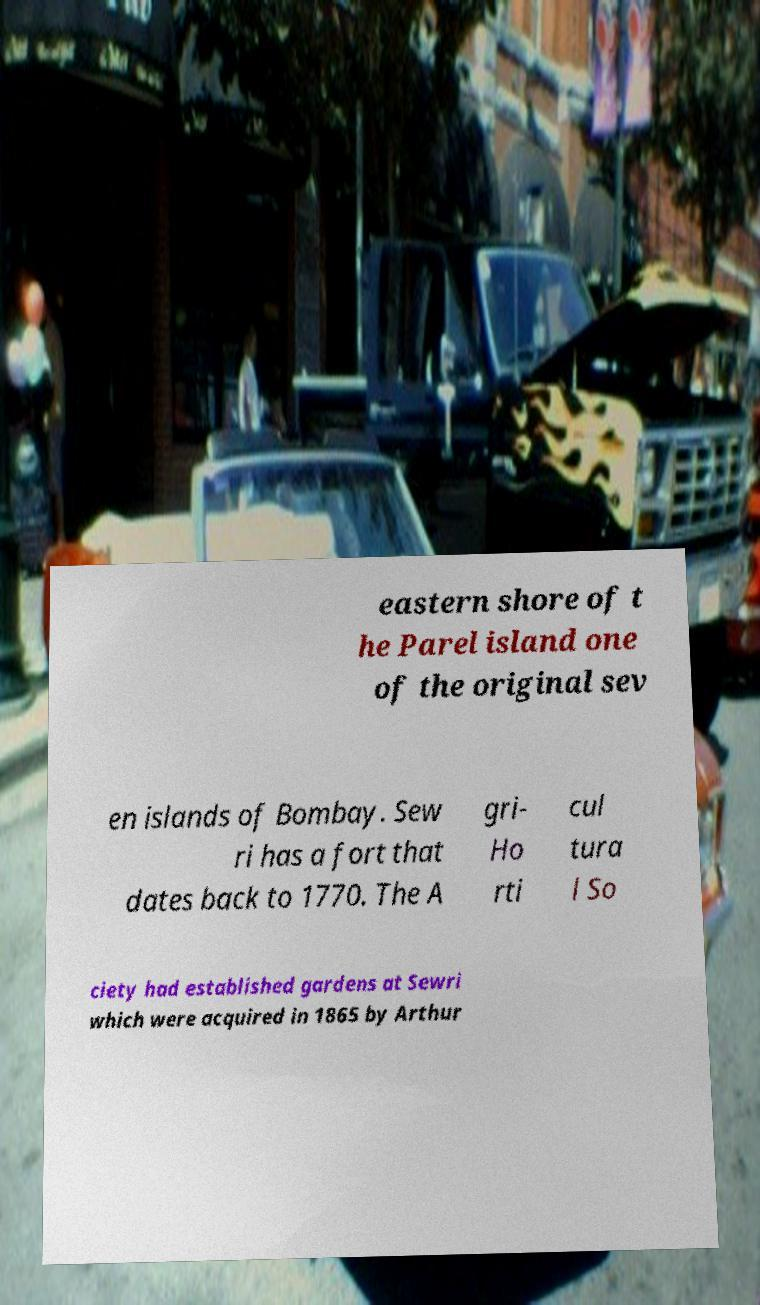I need the written content from this picture converted into text. Can you do that? eastern shore of t he Parel island one of the original sev en islands of Bombay. Sew ri has a fort that dates back to 1770. The A gri- Ho rti cul tura l So ciety had established gardens at Sewri which were acquired in 1865 by Arthur 